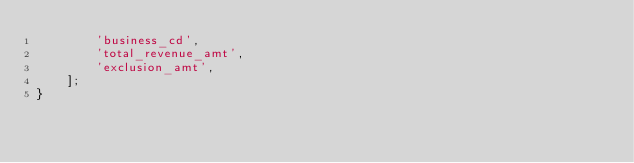<code> <loc_0><loc_0><loc_500><loc_500><_PHP_>        'business_cd',
        'total_revenue_amt',
        'exclusion_amt',
    ];
}
</code> 